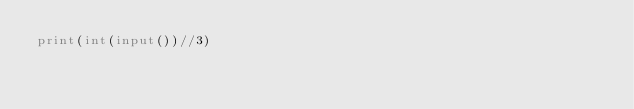Convert code to text. <code><loc_0><loc_0><loc_500><loc_500><_Python_>print(int(input())//3)</code> 